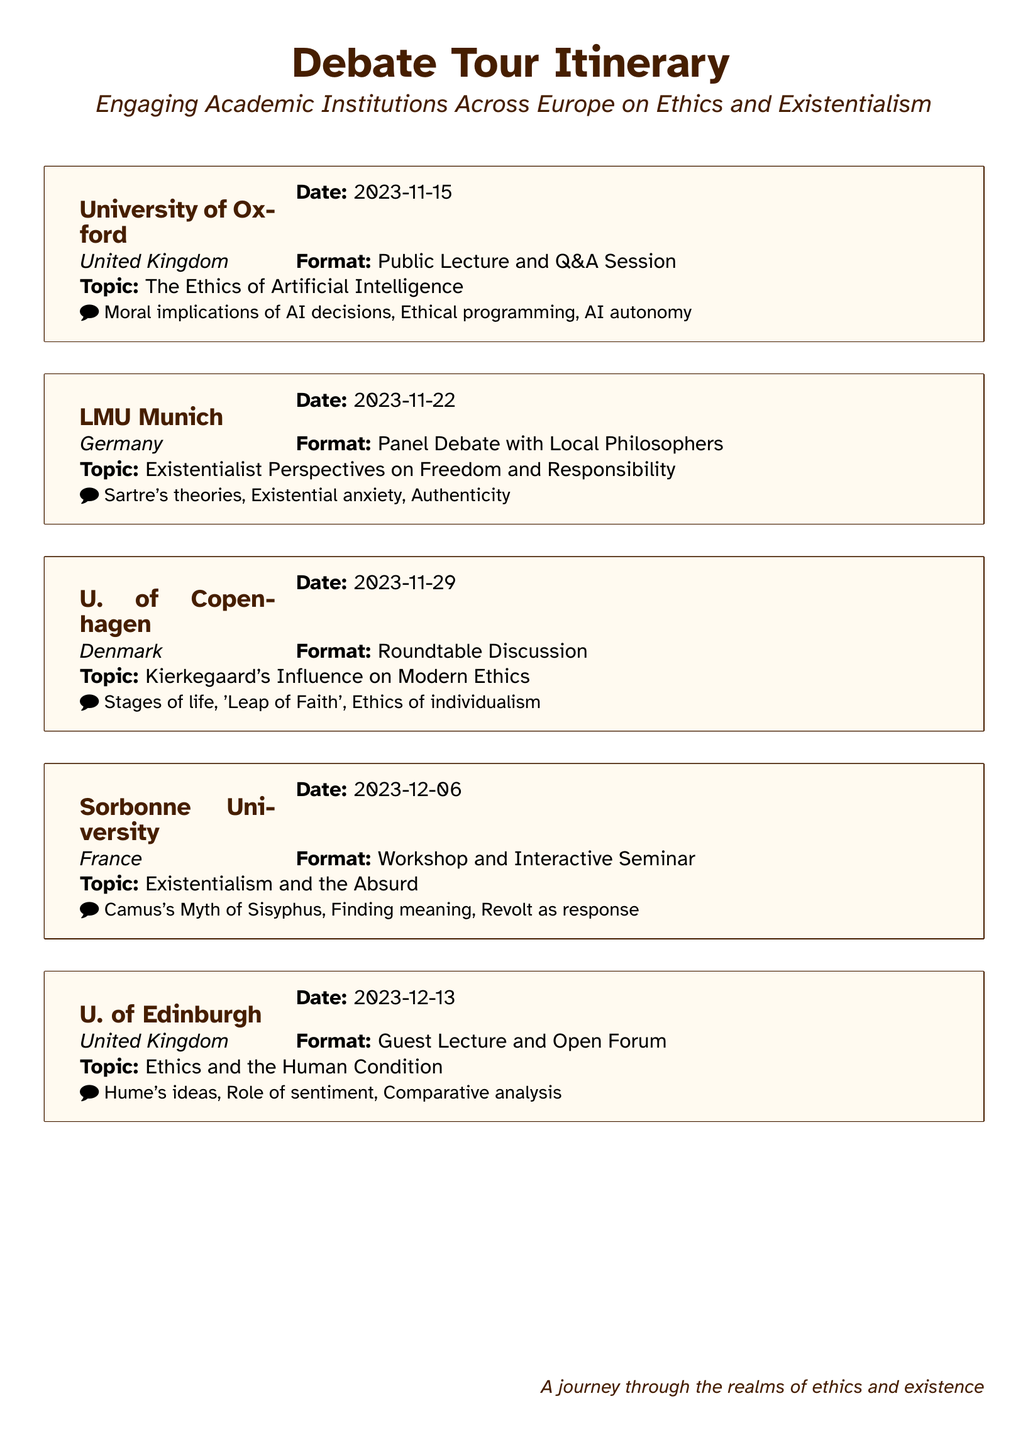What is the first event location? The first event is at the University of Oxford as listed in the itinerary.
Answer: University of Oxford What is the date of the event in Munich? The date for the LMU Munich event is specified in the itinerary as 2023-11-22.
Answer: 2023-11-22 What is the topic discussed at Sorbonne University? The topic at Sorbonne University is provided in the document and focuses on existentialism and the absurd.
Answer: Existentialism and the Absurd How is the format of the event in Copenhagen described? The format is mentioned as a roundtable discussion, detailing the type of engagement at the event.
Answer: Roundtable Discussion Which philosopher's theories are explored at LMU Munich? The document specifies that Sartre's theories are a focal point during the debate at LMU Munich.
Answer: Sartre's theories What is the primary focus of the event at the University of Edinburgh? The event's primary focus is specified in the document as ethics and the human condition.
Answer: Ethics and the Human Condition How many days apart are the events at Oxford and Munich? The difference in dates between the two events is calculated from the listed dates in the document.
Answer: 7 days What type of event format is offered at U. of Copenhagen? The format for the event at U. of Copenhagen is outlined in the itinerary as a roundtable discussion.
Answer: Roundtable Discussion What thematic element does the workshop at Sorbonne University address? The thematic element addressed in the workshop is described in relation to the absurd in existentialist thought.
Answer: Absurd 